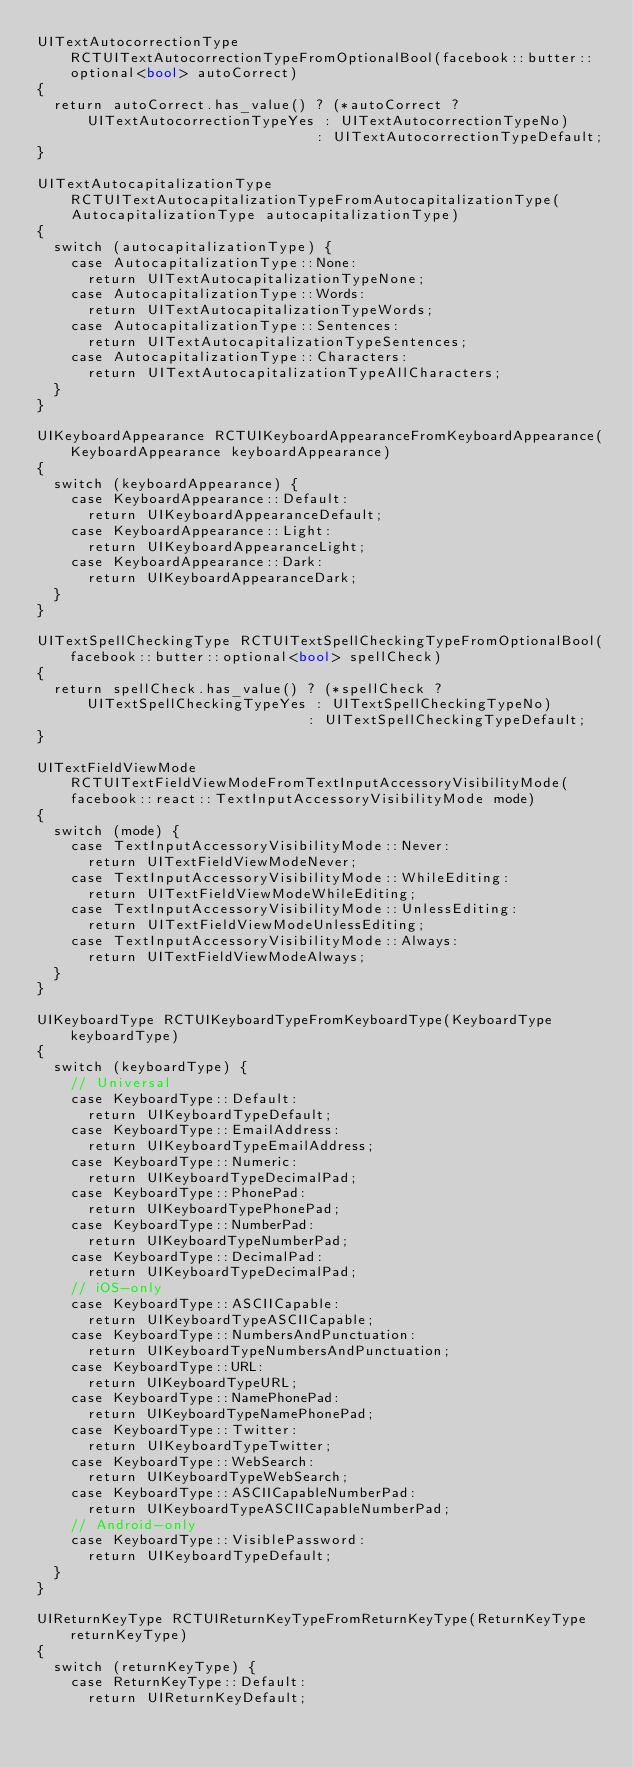Convert code to text. <code><loc_0><loc_0><loc_500><loc_500><_ObjectiveC_>UITextAutocorrectionType RCTUITextAutocorrectionTypeFromOptionalBool(facebook::butter::optional<bool> autoCorrect)
{
  return autoCorrect.has_value() ? (*autoCorrect ? UITextAutocorrectionTypeYes : UITextAutocorrectionTypeNo)
                                 : UITextAutocorrectionTypeDefault;
}

UITextAutocapitalizationType RCTUITextAutocapitalizationTypeFromAutocapitalizationType(
    AutocapitalizationType autocapitalizationType)
{
  switch (autocapitalizationType) {
    case AutocapitalizationType::None:
      return UITextAutocapitalizationTypeNone;
    case AutocapitalizationType::Words:
      return UITextAutocapitalizationTypeWords;
    case AutocapitalizationType::Sentences:
      return UITextAutocapitalizationTypeSentences;
    case AutocapitalizationType::Characters:
      return UITextAutocapitalizationTypeAllCharacters;
  }
}

UIKeyboardAppearance RCTUIKeyboardAppearanceFromKeyboardAppearance(KeyboardAppearance keyboardAppearance)
{
  switch (keyboardAppearance) {
    case KeyboardAppearance::Default:
      return UIKeyboardAppearanceDefault;
    case KeyboardAppearance::Light:
      return UIKeyboardAppearanceLight;
    case KeyboardAppearance::Dark:
      return UIKeyboardAppearanceDark;
  }
}

UITextSpellCheckingType RCTUITextSpellCheckingTypeFromOptionalBool(facebook::butter::optional<bool> spellCheck)
{
  return spellCheck.has_value() ? (*spellCheck ? UITextSpellCheckingTypeYes : UITextSpellCheckingTypeNo)
                                : UITextSpellCheckingTypeDefault;
}

UITextFieldViewMode RCTUITextFieldViewModeFromTextInputAccessoryVisibilityMode(
    facebook::react::TextInputAccessoryVisibilityMode mode)
{
  switch (mode) {
    case TextInputAccessoryVisibilityMode::Never:
      return UITextFieldViewModeNever;
    case TextInputAccessoryVisibilityMode::WhileEditing:
      return UITextFieldViewModeWhileEditing;
    case TextInputAccessoryVisibilityMode::UnlessEditing:
      return UITextFieldViewModeUnlessEditing;
    case TextInputAccessoryVisibilityMode::Always:
      return UITextFieldViewModeAlways;
  }
}

UIKeyboardType RCTUIKeyboardTypeFromKeyboardType(KeyboardType keyboardType)
{
  switch (keyboardType) {
    // Universal
    case KeyboardType::Default:
      return UIKeyboardTypeDefault;
    case KeyboardType::EmailAddress:
      return UIKeyboardTypeEmailAddress;
    case KeyboardType::Numeric:
      return UIKeyboardTypeDecimalPad;
    case KeyboardType::PhonePad:
      return UIKeyboardTypePhonePad;
    case KeyboardType::NumberPad:
      return UIKeyboardTypeNumberPad;
    case KeyboardType::DecimalPad:
      return UIKeyboardTypeDecimalPad;
    // iOS-only
    case KeyboardType::ASCIICapable:
      return UIKeyboardTypeASCIICapable;
    case KeyboardType::NumbersAndPunctuation:
      return UIKeyboardTypeNumbersAndPunctuation;
    case KeyboardType::URL:
      return UIKeyboardTypeURL;
    case KeyboardType::NamePhonePad:
      return UIKeyboardTypeNamePhonePad;
    case KeyboardType::Twitter:
      return UIKeyboardTypeTwitter;
    case KeyboardType::WebSearch:
      return UIKeyboardTypeWebSearch;
    case KeyboardType::ASCIICapableNumberPad:
      return UIKeyboardTypeASCIICapableNumberPad;
    // Android-only
    case KeyboardType::VisiblePassword:
      return UIKeyboardTypeDefault;
  }
}

UIReturnKeyType RCTUIReturnKeyTypeFromReturnKeyType(ReturnKeyType returnKeyType)
{
  switch (returnKeyType) {
    case ReturnKeyType::Default:
      return UIReturnKeyDefault;</code> 